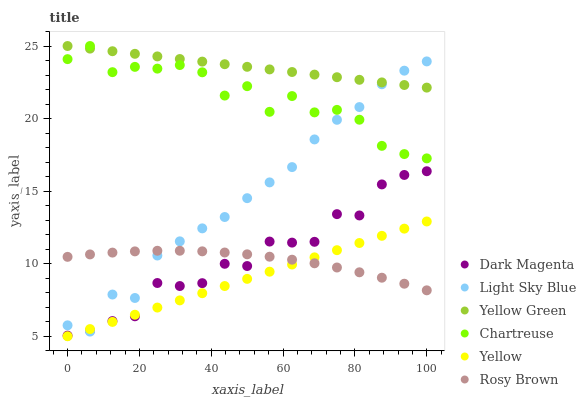Does Yellow have the minimum area under the curve?
Answer yes or no. Yes. Does Yellow Green have the maximum area under the curve?
Answer yes or no. Yes. Does Rosy Brown have the minimum area under the curve?
Answer yes or no. No. Does Rosy Brown have the maximum area under the curve?
Answer yes or no. No. Is Yellow the smoothest?
Answer yes or no. Yes. Is Chartreuse the roughest?
Answer yes or no. Yes. Is Rosy Brown the smoothest?
Answer yes or no. No. Is Rosy Brown the roughest?
Answer yes or no. No. Does Yellow have the lowest value?
Answer yes or no. Yes. Does Rosy Brown have the lowest value?
Answer yes or no. No. Does Yellow Green have the highest value?
Answer yes or no. Yes. Does Yellow have the highest value?
Answer yes or no. No. Is Yellow less than Chartreuse?
Answer yes or no. Yes. Is Chartreuse greater than Yellow?
Answer yes or no. Yes. Does Dark Magenta intersect Yellow?
Answer yes or no. Yes. Is Dark Magenta less than Yellow?
Answer yes or no. No. Is Dark Magenta greater than Yellow?
Answer yes or no. No. Does Yellow intersect Chartreuse?
Answer yes or no. No. 